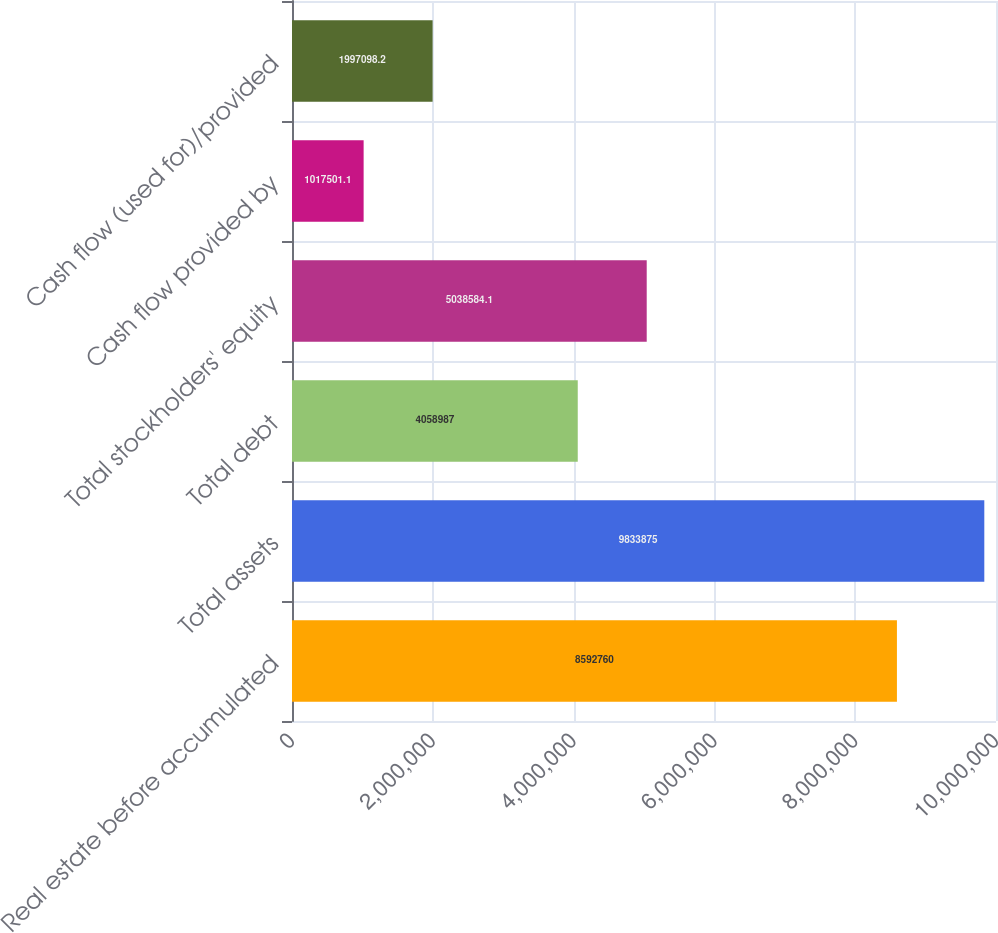<chart> <loc_0><loc_0><loc_500><loc_500><bar_chart><fcel>Real estate before accumulated<fcel>Total assets<fcel>Total debt<fcel>Total stockholders' equity<fcel>Cash flow provided by<fcel>Cash flow (used for)/provided<nl><fcel>8.59276e+06<fcel>9.83388e+06<fcel>4.05899e+06<fcel>5.03858e+06<fcel>1.0175e+06<fcel>1.9971e+06<nl></chart> 